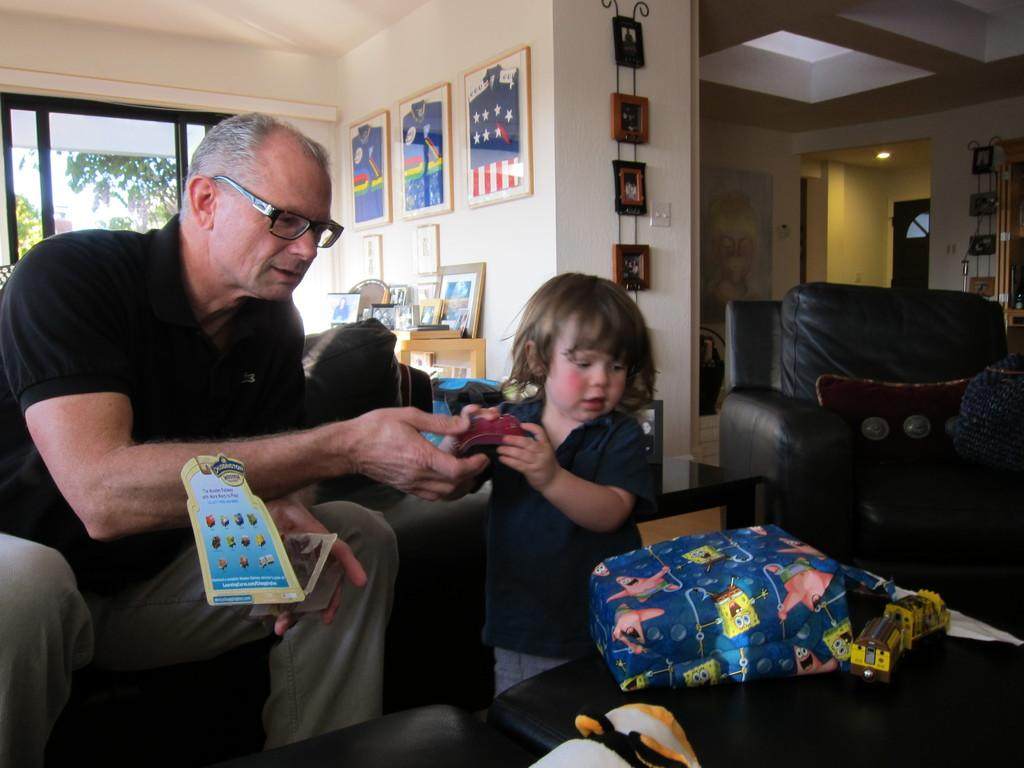What is the man in the image doing? The man is sitting on a chair in the image. What is the child doing in the image? The child is standing in the image. What objects are in front of the man and child? There is a bag and a toy in front of the man and child. What can be seen on the table at the back side of the image? There are frames on a table at the back side of the image. What type of train can be seen on the ground in the image? There is no train present in the image; it features a man sitting on a chair, a child standing, a bag, a toy, and frames on a table. 